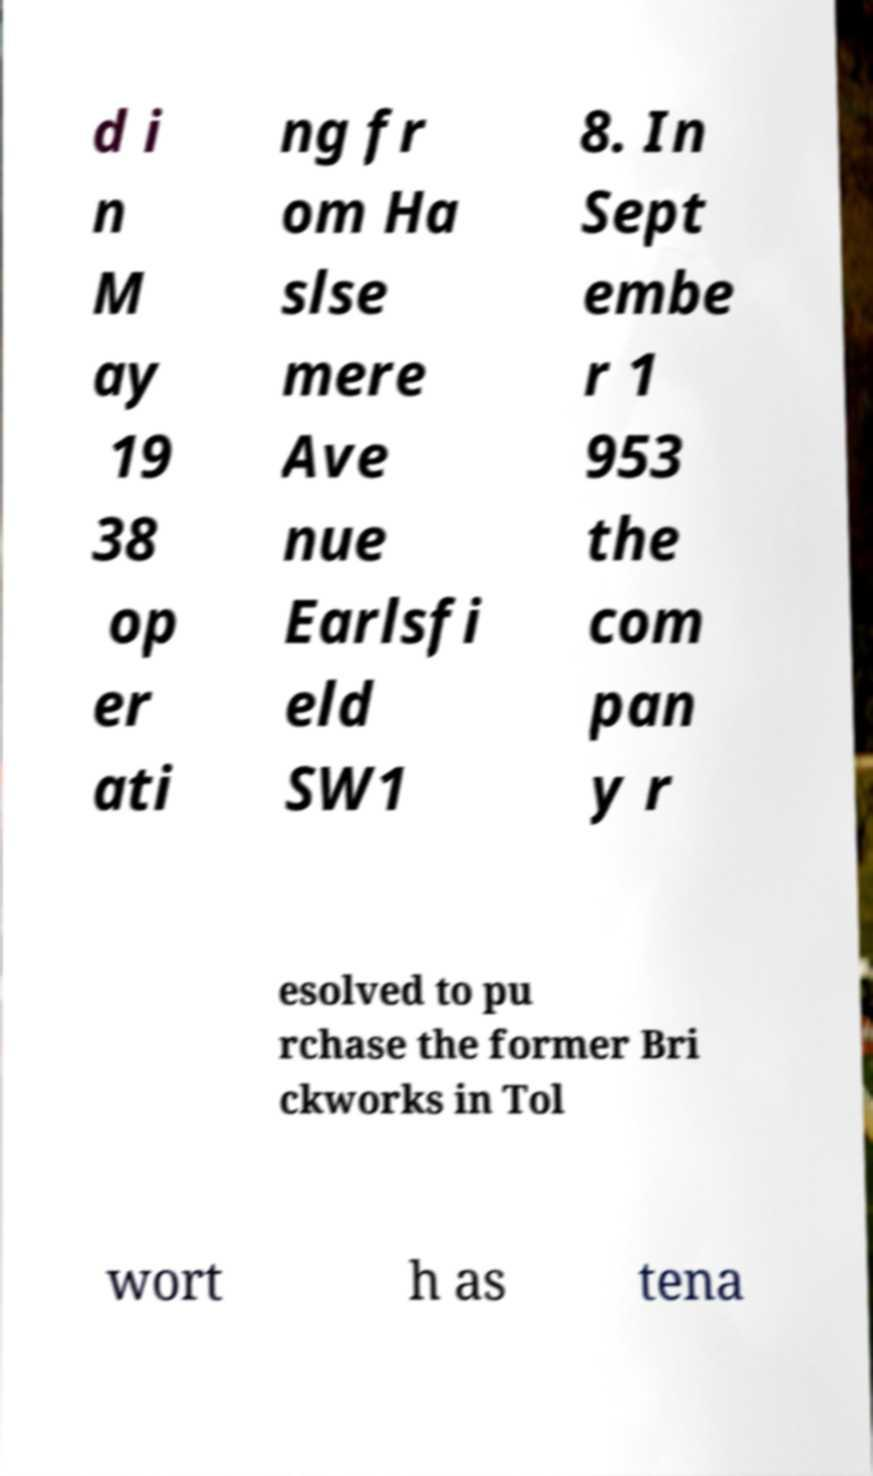Can you accurately transcribe the text from the provided image for me? d i n M ay 19 38 op er ati ng fr om Ha slse mere Ave nue Earlsfi eld SW1 8. In Sept embe r 1 953 the com pan y r esolved to pu rchase the former Bri ckworks in Tol wort h as tena 